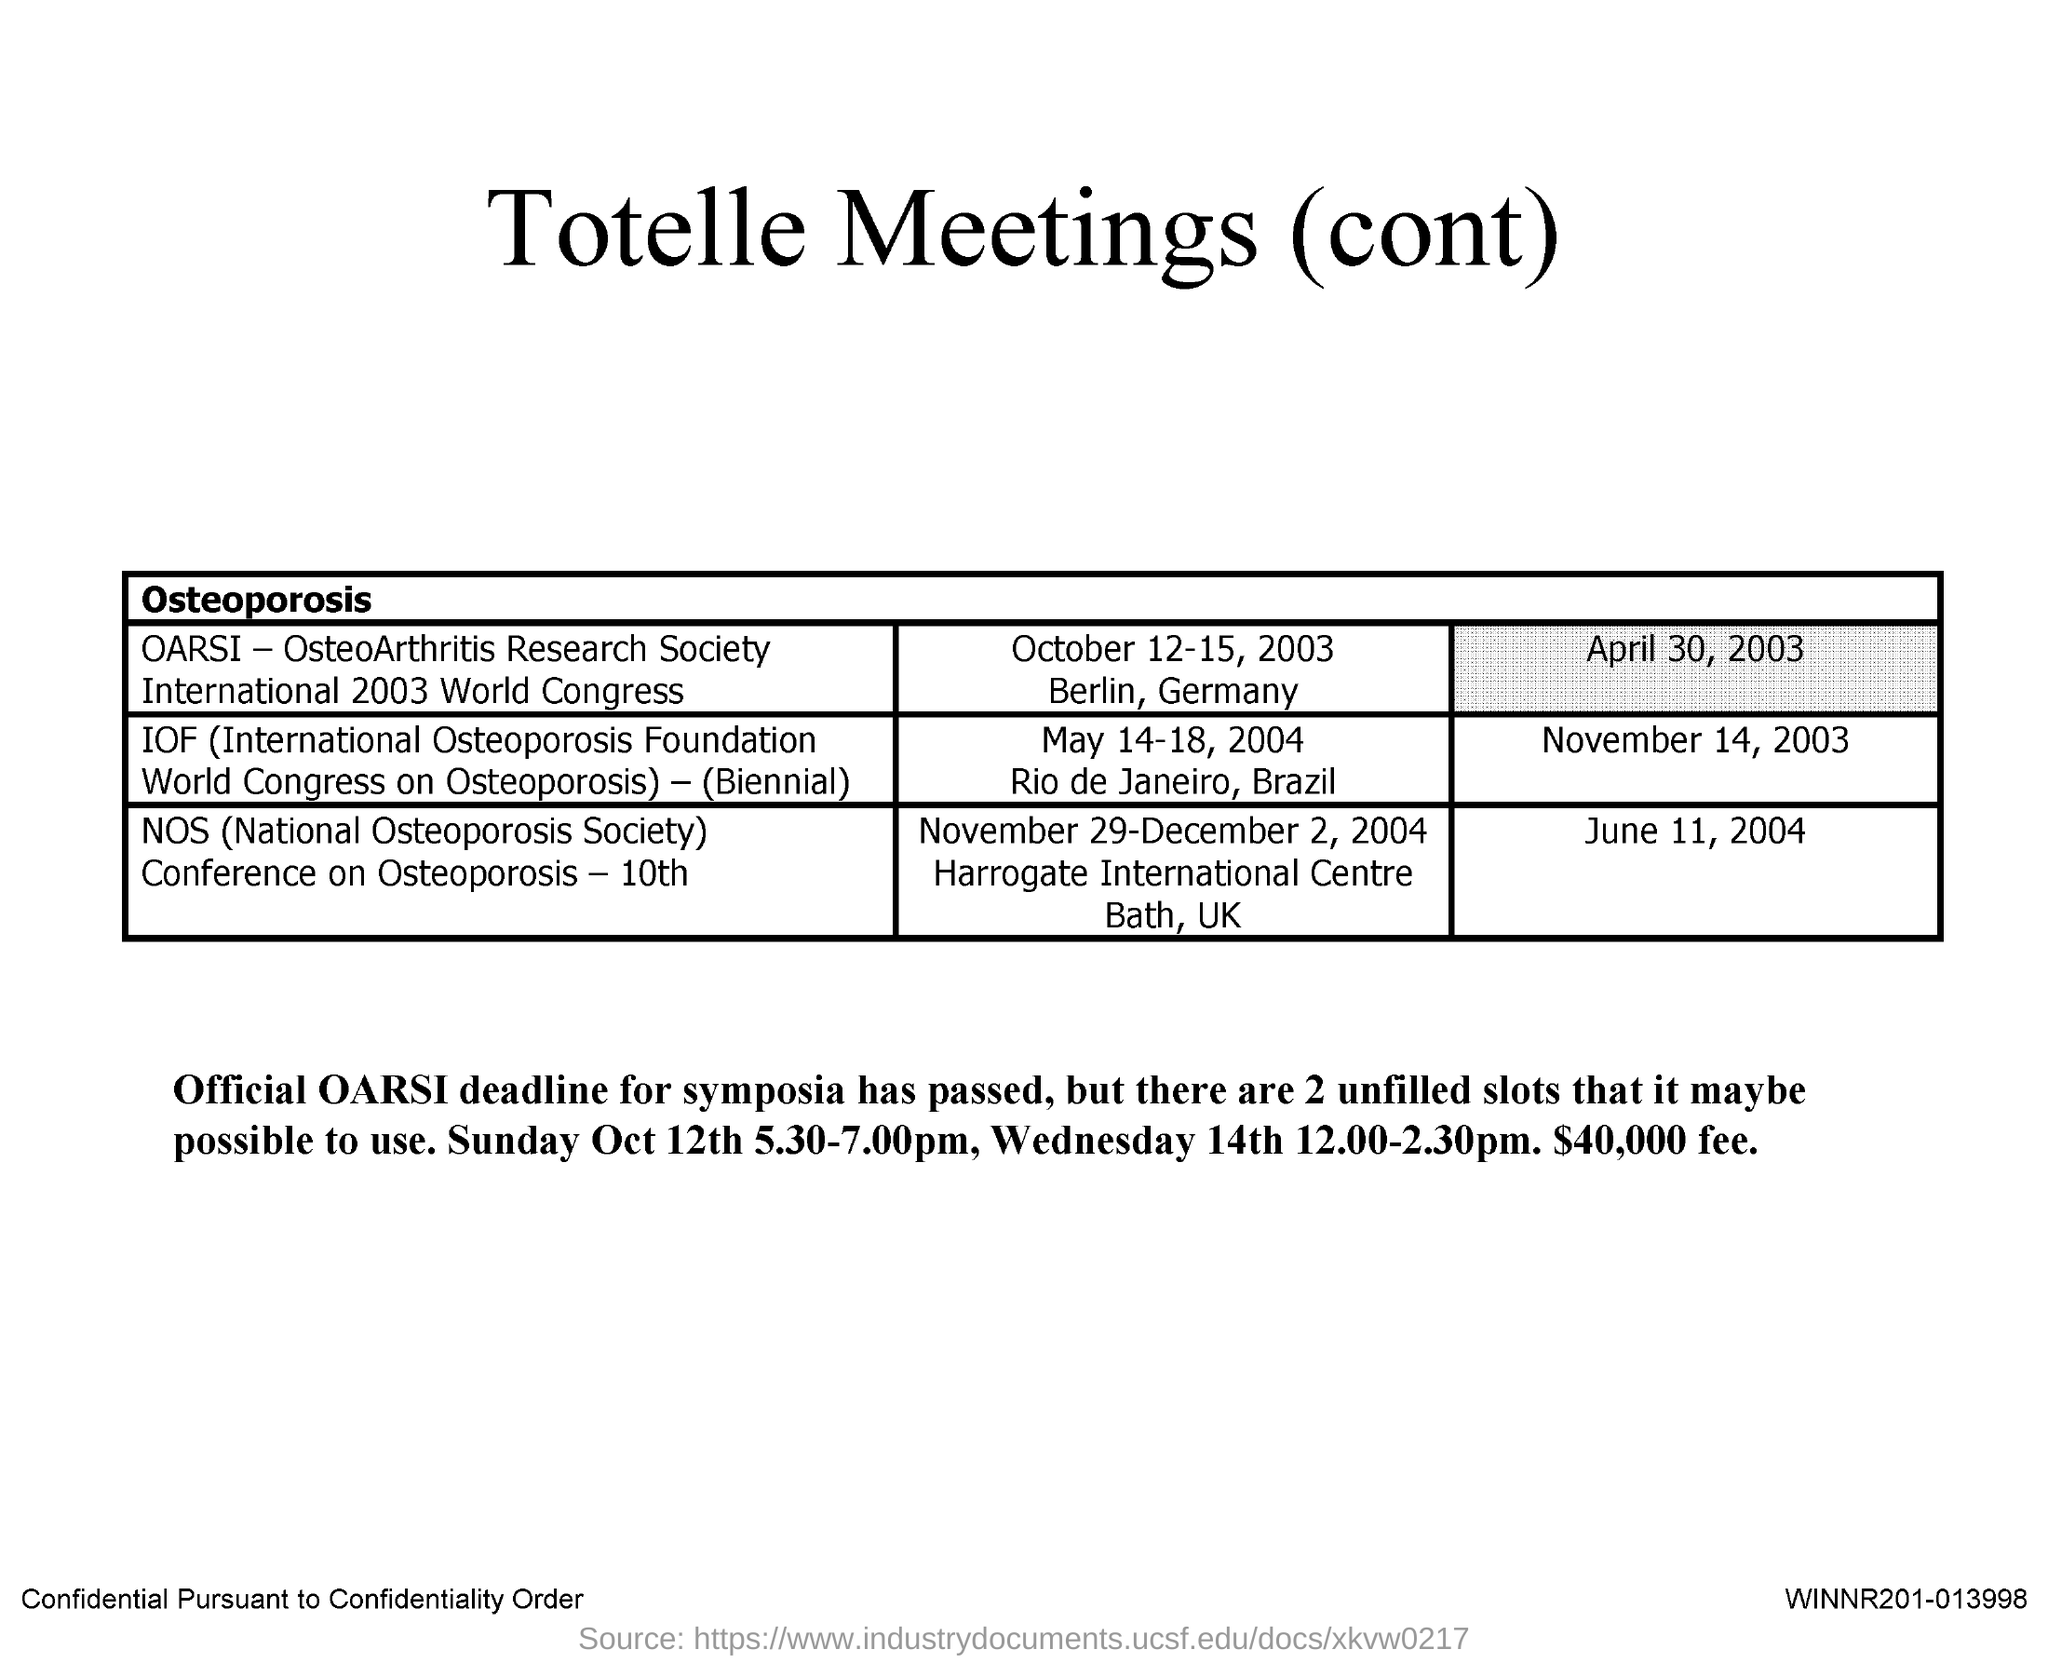What is the Full form of IOF?
Your answer should be very brief. International Osteoporosis Foundation. What is the Abbreviation for NOS ?
Ensure brevity in your answer.  (National Osteoporosis Society). 